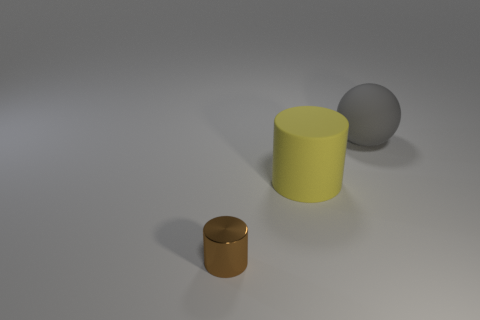Add 2 tiny brown cylinders. How many objects exist? 5 Subtract all balls. How many objects are left? 2 Add 1 brown rubber objects. How many brown rubber objects exist? 1 Subtract 0 red blocks. How many objects are left? 3 Subtract all large gray objects. Subtract all big yellow cylinders. How many objects are left? 1 Add 2 brown shiny cylinders. How many brown shiny cylinders are left? 3 